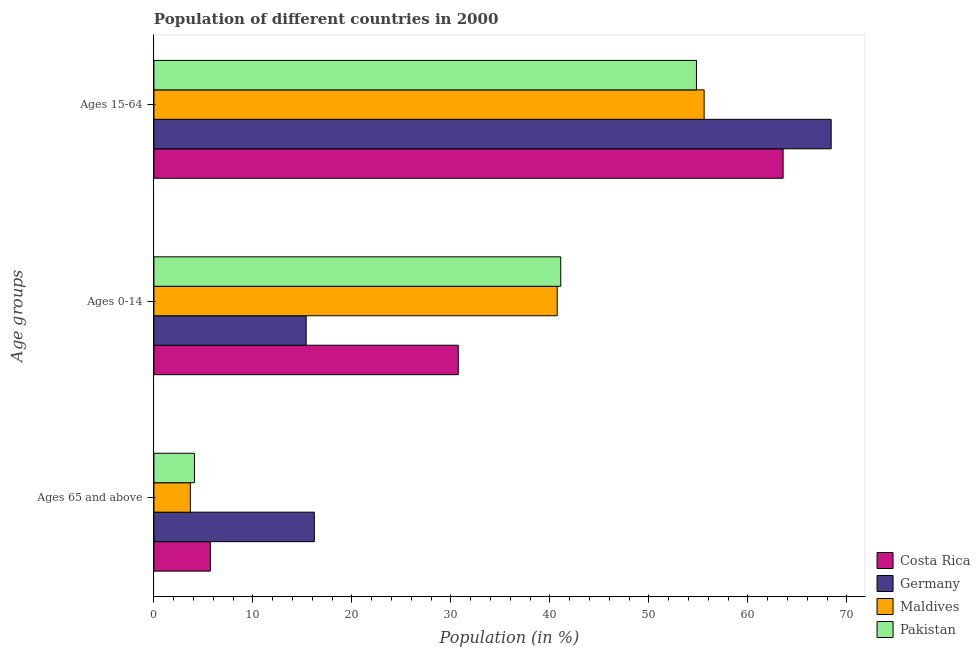How many different coloured bars are there?
Offer a very short reply. 4. Are the number of bars per tick equal to the number of legend labels?
Your answer should be very brief. Yes. What is the label of the 1st group of bars from the top?
Your response must be concise. Ages 15-64. What is the percentage of population within the age-group 0-14 in Pakistan?
Give a very brief answer. 41.1. Across all countries, what is the maximum percentage of population within the age-group 15-64?
Offer a very short reply. 68.41. Across all countries, what is the minimum percentage of population within the age-group 0-14?
Offer a terse response. 15.38. In which country was the percentage of population within the age-group 0-14 maximum?
Keep it short and to the point. Pakistan. In which country was the percentage of population within the age-group of 65 and above minimum?
Ensure brevity in your answer.  Maldives. What is the total percentage of population within the age-group 15-64 in the graph?
Offer a terse response. 242.36. What is the difference between the percentage of population within the age-group 0-14 in Pakistan and that in Costa Rica?
Your response must be concise. 10.35. What is the difference between the percentage of population within the age-group of 65 and above in Maldives and the percentage of population within the age-group 0-14 in Pakistan?
Ensure brevity in your answer.  -37.42. What is the average percentage of population within the age-group 15-64 per country?
Your answer should be very brief. 60.59. What is the difference between the percentage of population within the age-group of 65 and above and percentage of population within the age-group 0-14 in Costa Rica?
Ensure brevity in your answer.  -25.05. What is the ratio of the percentage of population within the age-group 0-14 in Germany to that in Maldives?
Ensure brevity in your answer.  0.38. What is the difference between the highest and the second highest percentage of population within the age-group of 65 and above?
Your response must be concise. 10.51. What is the difference between the highest and the lowest percentage of population within the age-group 0-14?
Ensure brevity in your answer.  25.72. Is the sum of the percentage of population within the age-group 15-64 in Maldives and Germany greater than the maximum percentage of population within the age-group of 65 and above across all countries?
Provide a succinct answer. Yes. What does the 3rd bar from the top in Ages 0-14 represents?
Provide a succinct answer. Germany. How many bars are there?
Your response must be concise. 12. Are the values on the major ticks of X-axis written in scientific E-notation?
Offer a terse response. No. Does the graph contain grids?
Ensure brevity in your answer.  No. Where does the legend appear in the graph?
Your response must be concise. Bottom right. What is the title of the graph?
Offer a very short reply. Population of different countries in 2000. What is the label or title of the X-axis?
Offer a terse response. Population (in %). What is the label or title of the Y-axis?
Your answer should be compact. Age groups. What is the Population (in %) in Costa Rica in Ages 65 and above?
Provide a short and direct response. 5.7. What is the Population (in %) in Germany in Ages 65 and above?
Offer a very short reply. 16.2. What is the Population (in %) of Maldives in Ages 65 and above?
Provide a short and direct response. 3.68. What is the Population (in %) in Pakistan in Ages 65 and above?
Your answer should be very brief. 4.1. What is the Population (in %) of Costa Rica in Ages 0-14?
Give a very brief answer. 30.74. What is the Population (in %) in Germany in Ages 0-14?
Offer a terse response. 15.38. What is the Population (in %) in Maldives in Ages 0-14?
Provide a succinct answer. 40.74. What is the Population (in %) of Pakistan in Ages 0-14?
Your response must be concise. 41.1. What is the Population (in %) in Costa Rica in Ages 15-64?
Your answer should be compact. 63.56. What is the Population (in %) of Germany in Ages 15-64?
Offer a terse response. 68.41. What is the Population (in %) of Maldives in Ages 15-64?
Your response must be concise. 55.58. What is the Population (in %) in Pakistan in Ages 15-64?
Your response must be concise. 54.81. Across all Age groups, what is the maximum Population (in %) in Costa Rica?
Provide a succinct answer. 63.56. Across all Age groups, what is the maximum Population (in %) of Germany?
Give a very brief answer. 68.41. Across all Age groups, what is the maximum Population (in %) of Maldives?
Ensure brevity in your answer.  55.58. Across all Age groups, what is the maximum Population (in %) in Pakistan?
Provide a short and direct response. 54.81. Across all Age groups, what is the minimum Population (in %) of Costa Rica?
Your response must be concise. 5.7. Across all Age groups, what is the minimum Population (in %) in Germany?
Your answer should be compact. 15.38. Across all Age groups, what is the minimum Population (in %) in Maldives?
Give a very brief answer. 3.68. Across all Age groups, what is the minimum Population (in %) in Pakistan?
Offer a terse response. 4.1. What is the total Population (in %) in Costa Rica in the graph?
Offer a terse response. 100. What is the difference between the Population (in %) in Costa Rica in Ages 65 and above and that in Ages 0-14?
Offer a very short reply. -25.05. What is the difference between the Population (in %) in Germany in Ages 65 and above and that in Ages 0-14?
Make the answer very short. 0.82. What is the difference between the Population (in %) of Maldives in Ages 65 and above and that in Ages 0-14?
Make the answer very short. -37.06. What is the difference between the Population (in %) of Pakistan in Ages 65 and above and that in Ages 0-14?
Keep it short and to the point. -37. What is the difference between the Population (in %) in Costa Rica in Ages 65 and above and that in Ages 15-64?
Give a very brief answer. -57.86. What is the difference between the Population (in %) in Germany in Ages 65 and above and that in Ages 15-64?
Give a very brief answer. -52.21. What is the difference between the Population (in %) in Maldives in Ages 65 and above and that in Ages 15-64?
Your answer should be very brief. -51.9. What is the difference between the Population (in %) in Pakistan in Ages 65 and above and that in Ages 15-64?
Your response must be concise. -50.71. What is the difference between the Population (in %) of Costa Rica in Ages 0-14 and that in Ages 15-64?
Your answer should be very brief. -32.82. What is the difference between the Population (in %) of Germany in Ages 0-14 and that in Ages 15-64?
Your answer should be very brief. -53.03. What is the difference between the Population (in %) of Maldives in Ages 0-14 and that in Ages 15-64?
Give a very brief answer. -14.84. What is the difference between the Population (in %) of Pakistan in Ages 0-14 and that in Ages 15-64?
Your response must be concise. -13.71. What is the difference between the Population (in %) in Costa Rica in Ages 65 and above and the Population (in %) in Germany in Ages 0-14?
Your answer should be compact. -9.68. What is the difference between the Population (in %) of Costa Rica in Ages 65 and above and the Population (in %) of Maldives in Ages 0-14?
Make the answer very short. -35.04. What is the difference between the Population (in %) in Costa Rica in Ages 65 and above and the Population (in %) in Pakistan in Ages 0-14?
Your response must be concise. -35.4. What is the difference between the Population (in %) of Germany in Ages 65 and above and the Population (in %) of Maldives in Ages 0-14?
Ensure brevity in your answer.  -24.54. What is the difference between the Population (in %) of Germany in Ages 65 and above and the Population (in %) of Pakistan in Ages 0-14?
Offer a terse response. -24.89. What is the difference between the Population (in %) in Maldives in Ages 65 and above and the Population (in %) in Pakistan in Ages 0-14?
Your answer should be compact. -37.42. What is the difference between the Population (in %) of Costa Rica in Ages 65 and above and the Population (in %) of Germany in Ages 15-64?
Provide a short and direct response. -62.72. What is the difference between the Population (in %) of Costa Rica in Ages 65 and above and the Population (in %) of Maldives in Ages 15-64?
Offer a very short reply. -49.88. What is the difference between the Population (in %) in Costa Rica in Ages 65 and above and the Population (in %) in Pakistan in Ages 15-64?
Provide a short and direct response. -49.11. What is the difference between the Population (in %) of Germany in Ages 65 and above and the Population (in %) of Maldives in Ages 15-64?
Your response must be concise. -39.38. What is the difference between the Population (in %) in Germany in Ages 65 and above and the Population (in %) in Pakistan in Ages 15-64?
Offer a terse response. -38.6. What is the difference between the Population (in %) of Maldives in Ages 65 and above and the Population (in %) of Pakistan in Ages 15-64?
Your response must be concise. -51.13. What is the difference between the Population (in %) of Costa Rica in Ages 0-14 and the Population (in %) of Germany in Ages 15-64?
Provide a short and direct response. -37.67. What is the difference between the Population (in %) in Costa Rica in Ages 0-14 and the Population (in %) in Maldives in Ages 15-64?
Make the answer very short. -24.84. What is the difference between the Population (in %) of Costa Rica in Ages 0-14 and the Population (in %) of Pakistan in Ages 15-64?
Ensure brevity in your answer.  -24.06. What is the difference between the Population (in %) of Germany in Ages 0-14 and the Population (in %) of Maldives in Ages 15-64?
Your response must be concise. -40.2. What is the difference between the Population (in %) of Germany in Ages 0-14 and the Population (in %) of Pakistan in Ages 15-64?
Your answer should be very brief. -39.43. What is the difference between the Population (in %) in Maldives in Ages 0-14 and the Population (in %) in Pakistan in Ages 15-64?
Offer a terse response. -14.07. What is the average Population (in %) in Costa Rica per Age groups?
Your answer should be very brief. 33.33. What is the average Population (in %) of Germany per Age groups?
Offer a very short reply. 33.33. What is the average Population (in %) of Maldives per Age groups?
Give a very brief answer. 33.33. What is the average Population (in %) of Pakistan per Age groups?
Offer a terse response. 33.33. What is the difference between the Population (in %) in Costa Rica and Population (in %) in Germany in Ages 65 and above?
Offer a terse response. -10.51. What is the difference between the Population (in %) of Costa Rica and Population (in %) of Maldives in Ages 65 and above?
Your answer should be very brief. 2.02. What is the difference between the Population (in %) of Costa Rica and Population (in %) of Pakistan in Ages 65 and above?
Your answer should be compact. 1.6. What is the difference between the Population (in %) in Germany and Population (in %) in Maldives in Ages 65 and above?
Provide a short and direct response. 12.53. What is the difference between the Population (in %) in Germany and Population (in %) in Pakistan in Ages 65 and above?
Your answer should be compact. 12.11. What is the difference between the Population (in %) of Maldives and Population (in %) of Pakistan in Ages 65 and above?
Give a very brief answer. -0.42. What is the difference between the Population (in %) of Costa Rica and Population (in %) of Germany in Ages 0-14?
Provide a short and direct response. 15.36. What is the difference between the Population (in %) in Costa Rica and Population (in %) in Maldives in Ages 0-14?
Your answer should be compact. -10. What is the difference between the Population (in %) in Costa Rica and Population (in %) in Pakistan in Ages 0-14?
Give a very brief answer. -10.35. What is the difference between the Population (in %) in Germany and Population (in %) in Maldives in Ages 0-14?
Your answer should be compact. -25.36. What is the difference between the Population (in %) of Germany and Population (in %) of Pakistan in Ages 0-14?
Your response must be concise. -25.72. What is the difference between the Population (in %) of Maldives and Population (in %) of Pakistan in Ages 0-14?
Offer a terse response. -0.36. What is the difference between the Population (in %) of Costa Rica and Population (in %) of Germany in Ages 15-64?
Give a very brief answer. -4.86. What is the difference between the Population (in %) in Costa Rica and Population (in %) in Maldives in Ages 15-64?
Provide a short and direct response. 7.98. What is the difference between the Population (in %) of Costa Rica and Population (in %) of Pakistan in Ages 15-64?
Make the answer very short. 8.75. What is the difference between the Population (in %) in Germany and Population (in %) in Maldives in Ages 15-64?
Ensure brevity in your answer.  12.84. What is the difference between the Population (in %) of Germany and Population (in %) of Pakistan in Ages 15-64?
Offer a very short reply. 13.61. What is the difference between the Population (in %) of Maldives and Population (in %) of Pakistan in Ages 15-64?
Your response must be concise. 0.77. What is the ratio of the Population (in %) in Costa Rica in Ages 65 and above to that in Ages 0-14?
Provide a succinct answer. 0.19. What is the ratio of the Population (in %) of Germany in Ages 65 and above to that in Ages 0-14?
Make the answer very short. 1.05. What is the ratio of the Population (in %) of Maldives in Ages 65 and above to that in Ages 0-14?
Make the answer very short. 0.09. What is the ratio of the Population (in %) of Pakistan in Ages 65 and above to that in Ages 0-14?
Provide a succinct answer. 0.1. What is the ratio of the Population (in %) in Costa Rica in Ages 65 and above to that in Ages 15-64?
Give a very brief answer. 0.09. What is the ratio of the Population (in %) of Germany in Ages 65 and above to that in Ages 15-64?
Your answer should be very brief. 0.24. What is the ratio of the Population (in %) of Maldives in Ages 65 and above to that in Ages 15-64?
Offer a very short reply. 0.07. What is the ratio of the Population (in %) of Pakistan in Ages 65 and above to that in Ages 15-64?
Provide a succinct answer. 0.07. What is the ratio of the Population (in %) of Costa Rica in Ages 0-14 to that in Ages 15-64?
Ensure brevity in your answer.  0.48. What is the ratio of the Population (in %) in Germany in Ages 0-14 to that in Ages 15-64?
Offer a terse response. 0.22. What is the ratio of the Population (in %) in Maldives in Ages 0-14 to that in Ages 15-64?
Your answer should be compact. 0.73. What is the ratio of the Population (in %) of Pakistan in Ages 0-14 to that in Ages 15-64?
Keep it short and to the point. 0.75. What is the difference between the highest and the second highest Population (in %) in Costa Rica?
Your answer should be compact. 32.82. What is the difference between the highest and the second highest Population (in %) in Germany?
Provide a succinct answer. 52.21. What is the difference between the highest and the second highest Population (in %) of Maldives?
Give a very brief answer. 14.84. What is the difference between the highest and the second highest Population (in %) in Pakistan?
Your answer should be very brief. 13.71. What is the difference between the highest and the lowest Population (in %) in Costa Rica?
Ensure brevity in your answer.  57.86. What is the difference between the highest and the lowest Population (in %) of Germany?
Offer a very short reply. 53.03. What is the difference between the highest and the lowest Population (in %) in Maldives?
Make the answer very short. 51.9. What is the difference between the highest and the lowest Population (in %) of Pakistan?
Your answer should be compact. 50.71. 